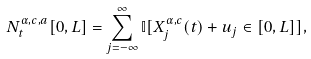Convert formula to latex. <formula><loc_0><loc_0><loc_500><loc_500>N _ { t } ^ { \alpha , c , a } [ 0 , L ] = \sum _ { j = - \infty } ^ { \infty } \mathbb { I } [ X _ { j } ^ { \alpha , c } ( t ) + u _ { j } \in [ 0 , L ] ] ,</formula> 